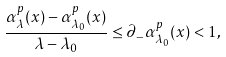<formula> <loc_0><loc_0><loc_500><loc_500>\frac { \alpha _ { \lambda } ^ { p } ( x ) - \alpha _ { \lambda _ { 0 } } ^ { p } ( x ) } { \lambda - \lambda _ { 0 } } \leq \partial _ { - } \alpha _ { \lambda _ { 0 } } ^ { p } ( x ) < 1 ,</formula> 